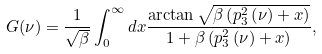<formula> <loc_0><loc_0><loc_500><loc_500>G ( \nu ) = \frac { 1 } { \sqrt { \beta } } \int _ { 0 } ^ { \infty } d x \frac { \arctan \sqrt { \beta \left ( p _ { 3 } ^ { 2 } \left ( \nu \right ) + x \right ) } } { 1 + \beta \left ( p _ { 3 } ^ { 2 } \left ( \nu \right ) + x \right ) } ,</formula> 